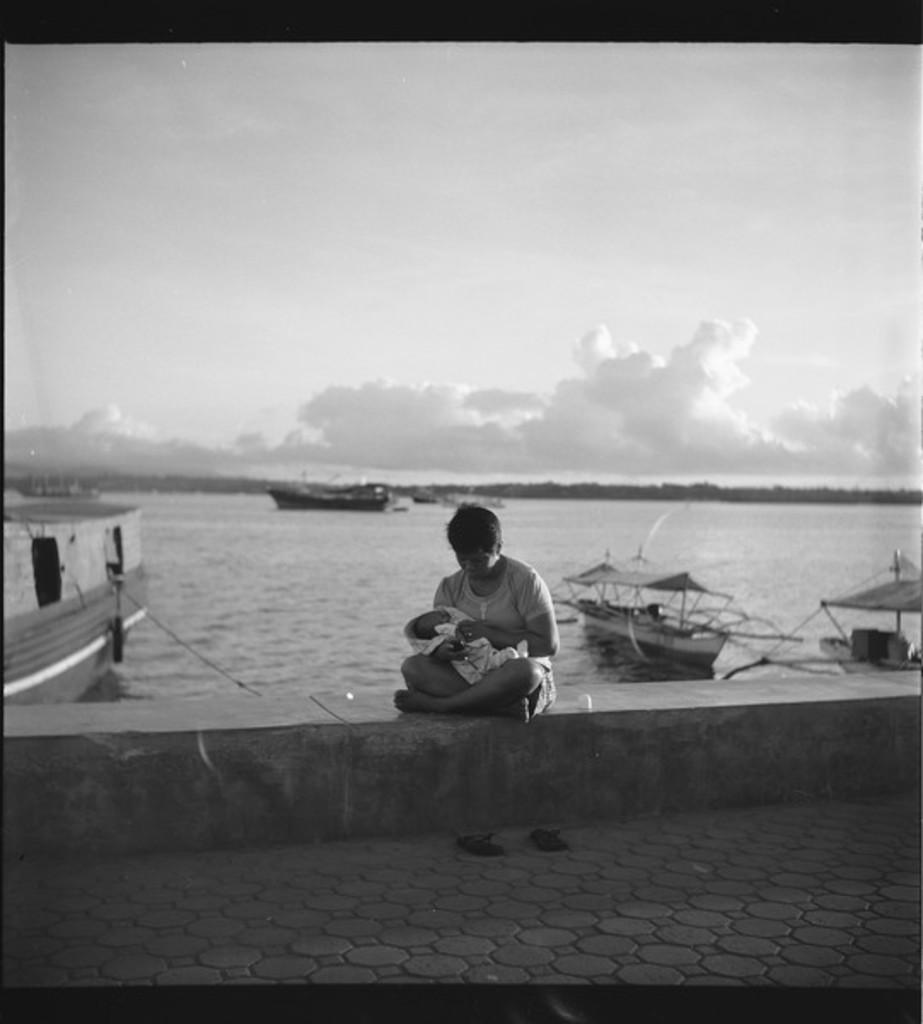What is the person in the image doing? The person is holding a baby in the image. Where is the person sitting? The person is sitting on a wall in the image. What is the color scheme of the image? The image is in black and white. What can be seen on the water surface in the image? There are boats on the water surface in the image. What is visible in the background of the image? The sky is visible in the image. What type of orange is being peeled by the laborer in the image? There is no orange or laborer present in the image. What agreement was reached between the two parties in the image? There is no indication of any agreement or negotiation in the image. 